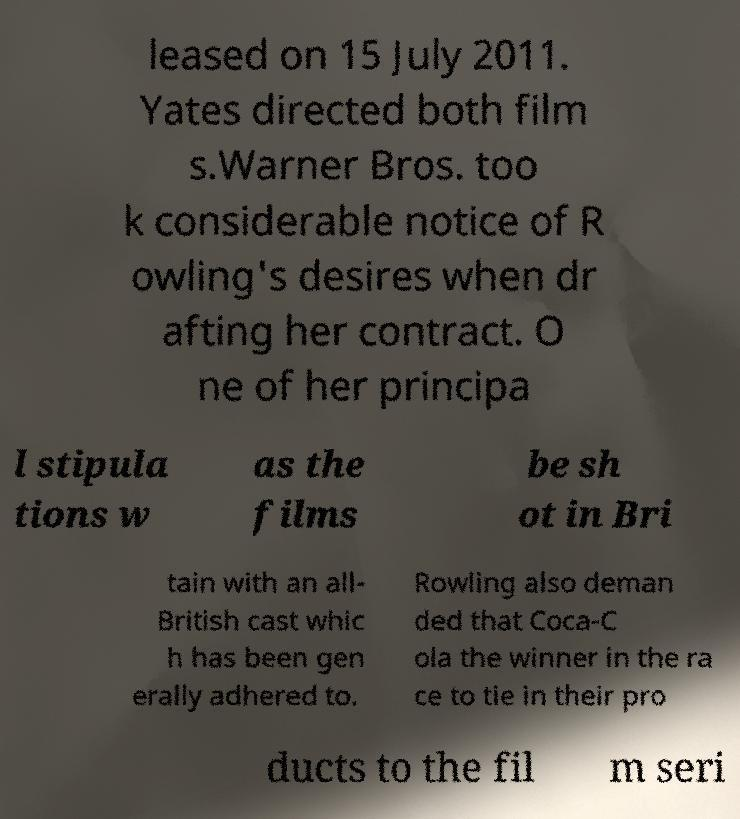Could you assist in decoding the text presented in this image and type it out clearly? leased on 15 July 2011. Yates directed both film s.Warner Bros. too k considerable notice of R owling's desires when dr afting her contract. O ne of her principa l stipula tions w as the films be sh ot in Bri tain with an all- British cast whic h has been gen erally adhered to. Rowling also deman ded that Coca-C ola the winner in the ra ce to tie in their pro ducts to the fil m seri 